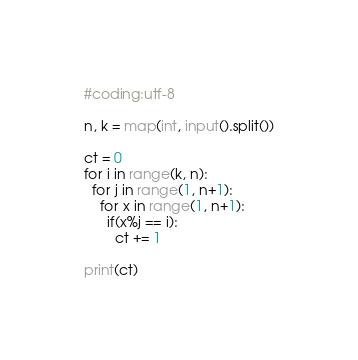Convert code to text. <code><loc_0><loc_0><loc_500><loc_500><_Python_>#coding:utf-8

n, k = map(int, input().split())

ct = 0
for i in range(k, n):
  for j in range(1, n+1):
    for x in range(1, n+1):
      if(x%j == i):
        ct += 1

print(ct)</code> 